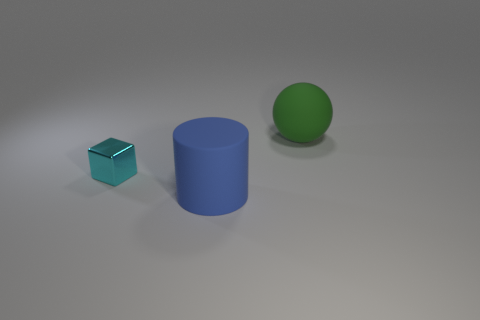How big is the matte thing behind the tiny cube?
Make the answer very short. Large. Is there a big blue thing left of the green object behind the matte object in front of the cyan object?
Provide a short and direct response. Yes. What number of balls are either small metallic objects or blue matte objects?
Your answer should be compact. 0. There is a big matte thing behind the big matte thing that is in front of the green rubber sphere; what shape is it?
Offer a terse response. Sphere. There is a thing to the left of the large rubber thing in front of the large rubber object to the right of the large matte cylinder; what is its size?
Keep it short and to the point. Small. Is the size of the cylinder the same as the green rubber ball?
Your response must be concise. Yes. What number of things are big objects or tiny cyan blocks?
Provide a succinct answer. 3. How big is the thing that is left of the big matte object left of the green object?
Your answer should be very brief. Small. The green ball is what size?
Give a very brief answer. Large. What shape is the thing that is in front of the big matte sphere and behind the large blue rubber object?
Your response must be concise. Cube. 